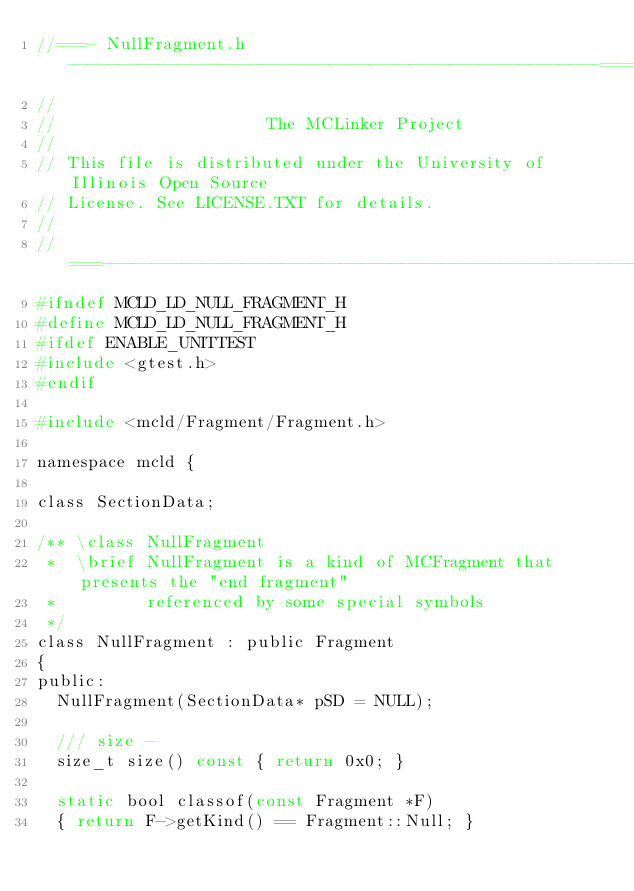Convert code to text. <code><loc_0><loc_0><loc_500><loc_500><_C_>//===- NullFragment.h -----------------------------------------------------===//
//
//                     The MCLinker Project
//
// This file is distributed under the University of Illinois Open Source
// License. See LICENSE.TXT for details.
//
//===----------------------------------------------------------------------===//
#ifndef MCLD_LD_NULL_FRAGMENT_H
#define MCLD_LD_NULL_FRAGMENT_H
#ifdef ENABLE_UNITTEST
#include <gtest.h>
#endif

#include <mcld/Fragment/Fragment.h>

namespace mcld {

class SectionData;

/** \class NullFragment
 *  \brief NullFragment is a kind of MCFragment that presents the "end fragment"
 *         referenced by some special symbols
 */
class NullFragment : public Fragment
{
public:
  NullFragment(SectionData* pSD = NULL);

  /// size -
  size_t size() const { return 0x0; }

  static bool classof(const Fragment *F)
  { return F->getKind() == Fragment::Null; }
</code> 